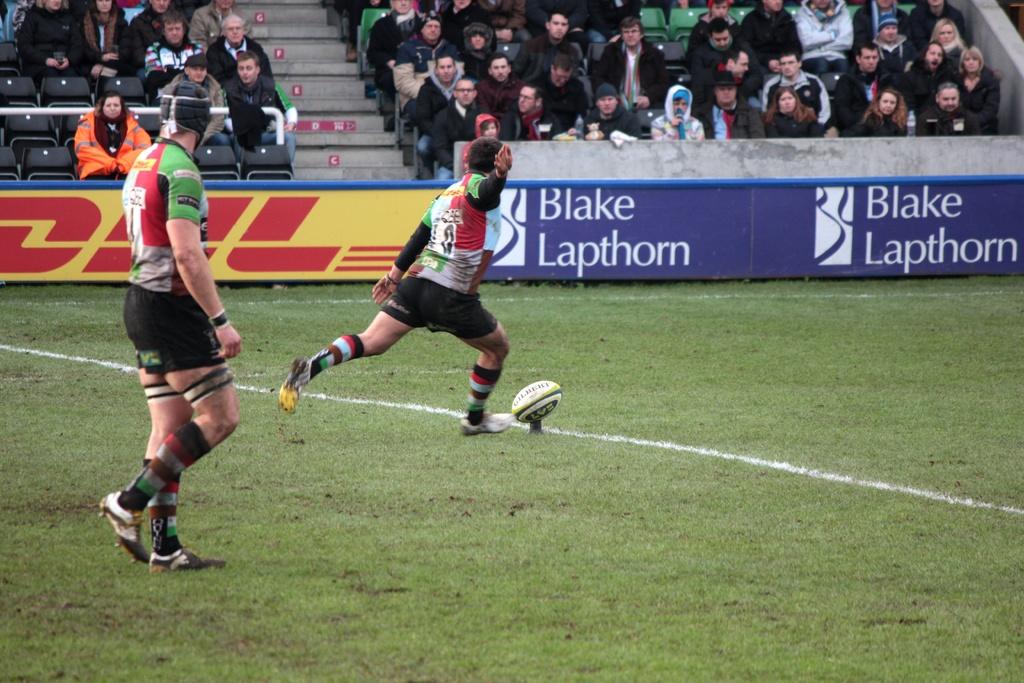What brand or name is on the wall of the stands of this stadium?
Offer a terse response. Blake lapthorn. Who is the sponsor in red?
Offer a very short reply. Dhl. 